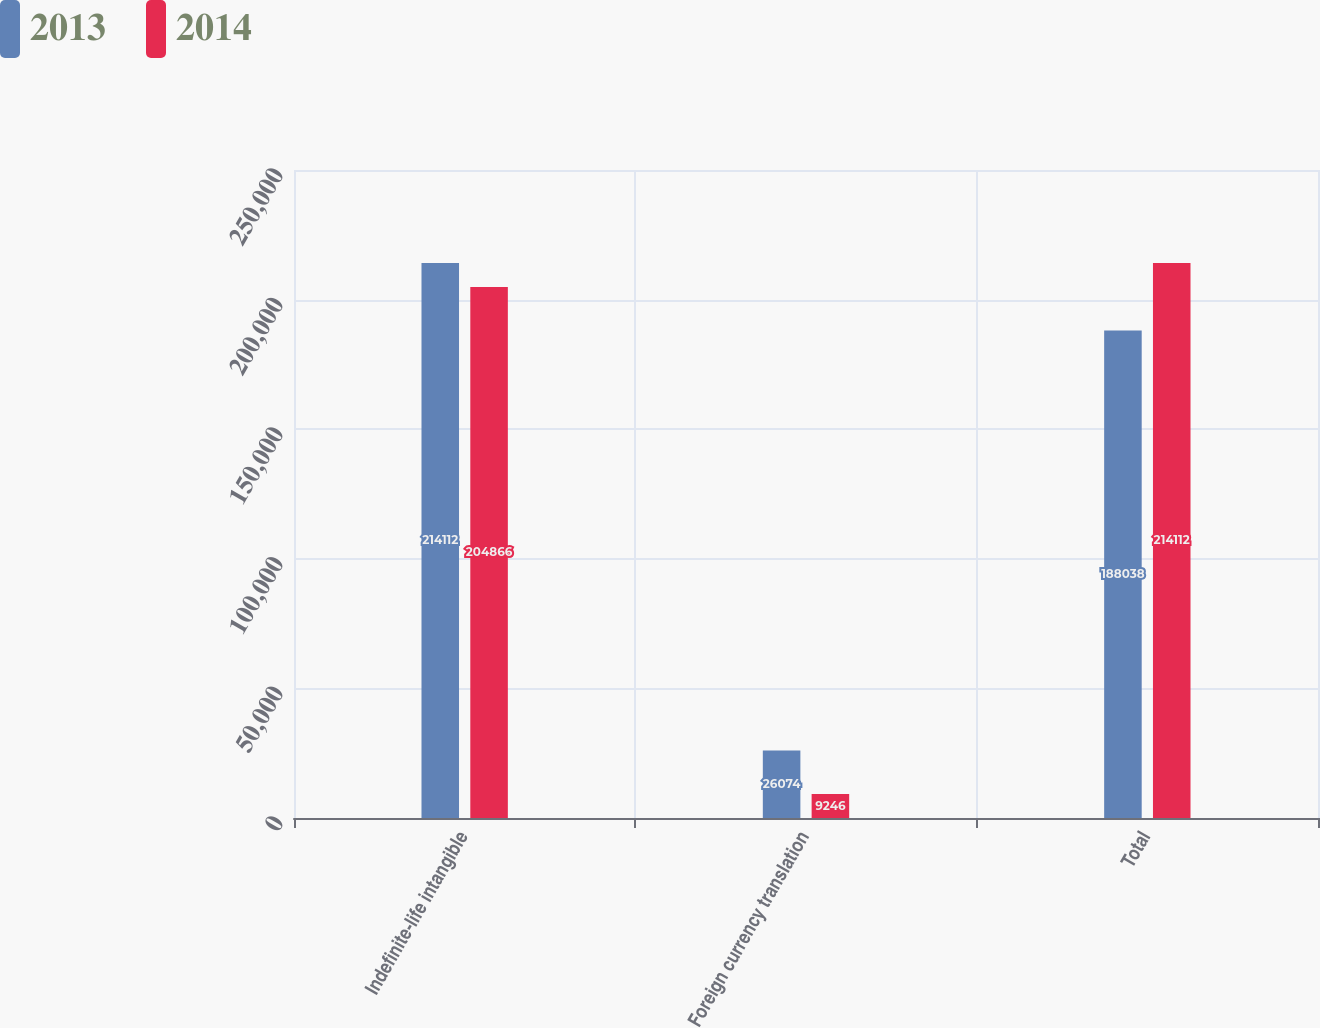<chart> <loc_0><loc_0><loc_500><loc_500><stacked_bar_chart><ecel><fcel>Indefinite-life intangible<fcel>Foreign currency translation<fcel>Total<nl><fcel>2013<fcel>214112<fcel>26074<fcel>188038<nl><fcel>2014<fcel>204866<fcel>9246<fcel>214112<nl></chart> 